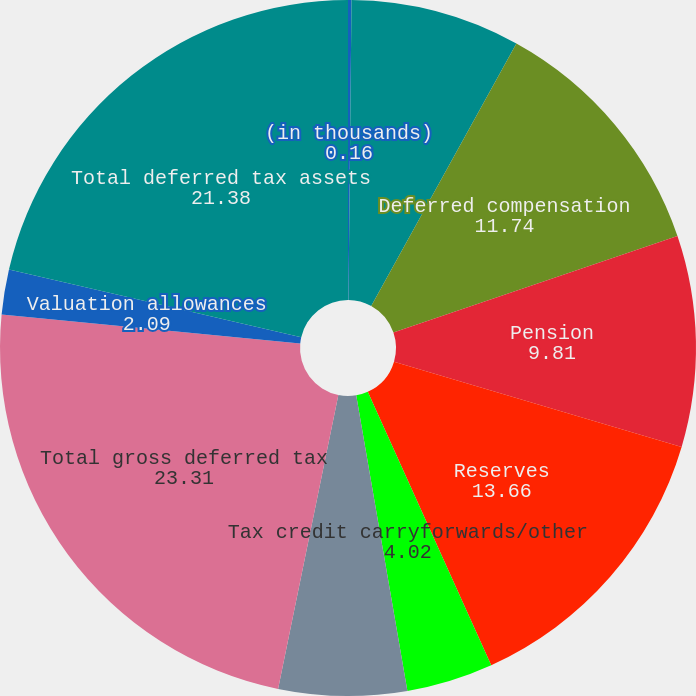Convert chart. <chart><loc_0><loc_0><loc_500><loc_500><pie_chart><fcel>(in thousands)<fcel>Accounts receivable<fcel>Deferred compensation<fcel>Pension<fcel>Reserves<fcel>Tax credit carryforwards/other<fcel>Net operating loss<fcel>Total gross deferred tax<fcel>Valuation allowances<fcel>Total deferred tax assets<nl><fcel>0.16%<fcel>7.88%<fcel>11.74%<fcel>9.81%<fcel>13.66%<fcel>4.02%<fcel>5.95%<fcel>23.31%<fcel>2.09%<fcel>21.38%<nl></chart> 